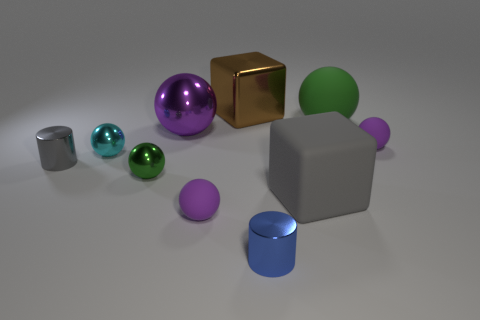Subtract all blue blocks. How many purple spheres are left? 3 Subtract 3 spheres. How many spheres are left? 3 Subtract all cyan shiny spheres. How many spheres are left? 5 Subtract all cyan balls. How many balls are left? 5 Subtract all gray balls. Subtract all red cylinders. How many balls are left? 6 Subtract all cubes. How many objects are left? 8 Add 4 gray things. How many gray things are left? 6 Add 2 tiny metal balls. How many tiny metal balls exist? 4 Subtract 1 gray cylinders. How many objects are left? 9 Subtract all green balls. Subtract all tiny blue metal objects. How many objects are left? 7 